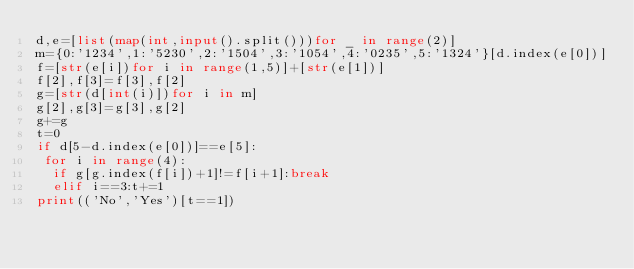<code> <loc_0><loc_0><loc_500><loc_500><_Python_>d,e=[list(map(int,input().split()))for _ in range(2)]
m={0:'1234',1:'5230',2:'1504',3:'1054',4:'0235',5:'1324'}[d.index(e[0])]
f=[str(e[i])for i in range(1,5)]+[str(e[1])]
f[2],f[3]=f[3],f[2]
g=[str(d[int(i)])for i in m]
g[2],g[3]=g[3],g[2]
g+=g
t=0
if d[5-d.index(e[0])]==e[5]:
 for i in range(4):
  if g[g.index(f[i])+1]!=f[i+1]:break
  elif i==3:t+=1
print(('No','Yes')[t==1])</code> 